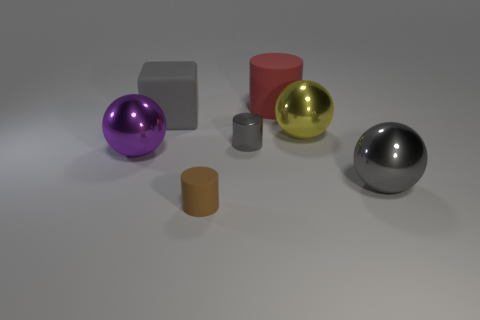Do the big metallic object right of the yellow sphere and the tiny object that is to the right of the brown rubber cylinder have the same color?
Ensure brevity in your answer.  Yes. There is a cube that is the same color as the small shiny cylinder; what material is it?
Your answer should be very brief. Rubber. Is there a shiny ball of the same color as the tiny metallic cylinder?
Your answer should be compact. Yes. How many cylinders are the same color as the rubber block?
Make the answer very short. 1. Are there more small metal things than small metallic cubes?
Ensure brevity in your answer.  Yes. What is the material of the large purple ball?
Provide a succinct answer. Metal. There is a brown thing that is the same shape as the tiny gray thing; what size is it?
Offer a very short reply. Small. Is there a large matte block in front of the metal sphere that is on the left side of the big red cylinder?
Your response must be concise. No. Is the big rubber cylinder the same color as the small metallic thing?
Offer a very short reply. No. What number of other objects are the same shape as the large yellow metal object?
Provide a succinct answer. 2. 